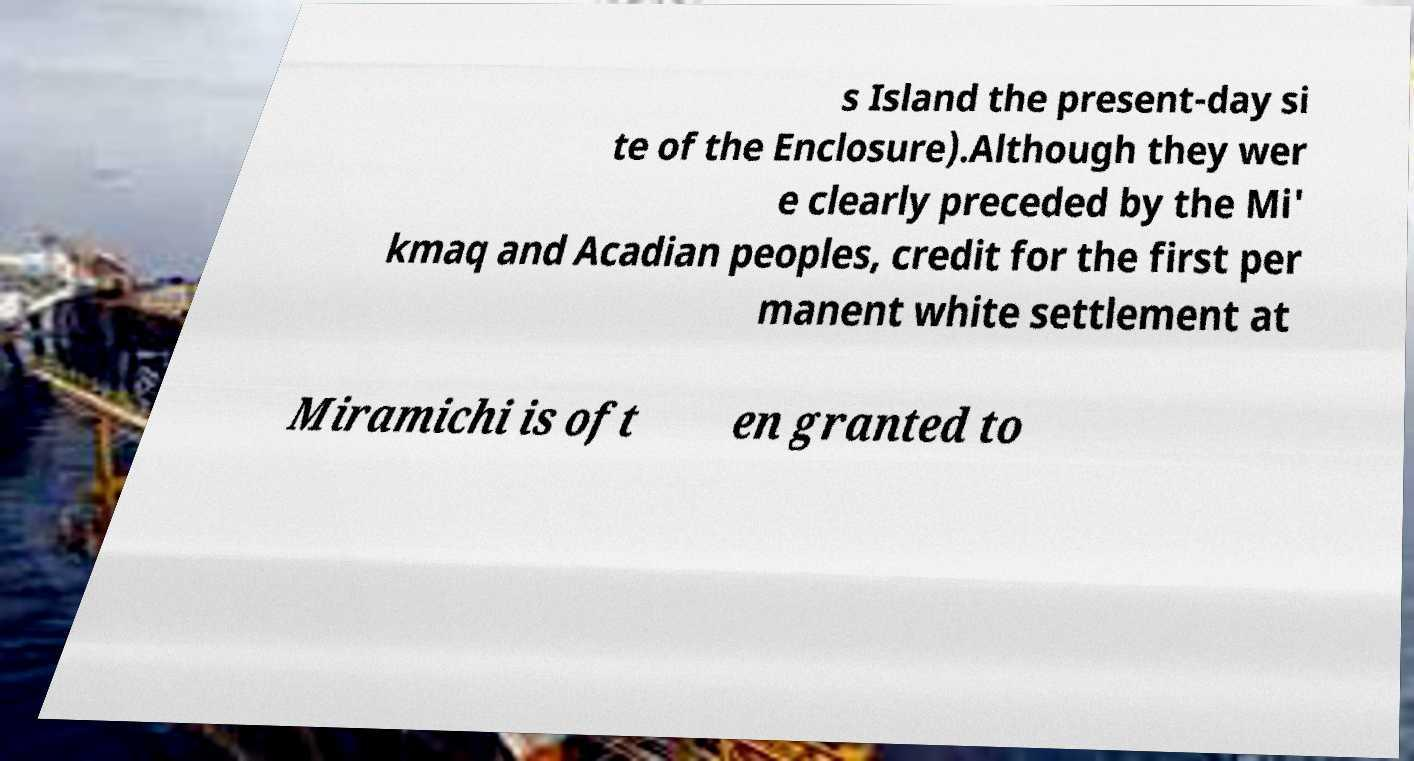Could you extract and type out the text from this image? s Island the present-day si te of the Enclosure).Although they wer e clearly preceded by the Mi' kmaq and Acadian peoples, credit for the first per manent white settlement at Miramichi is oft en granted to 